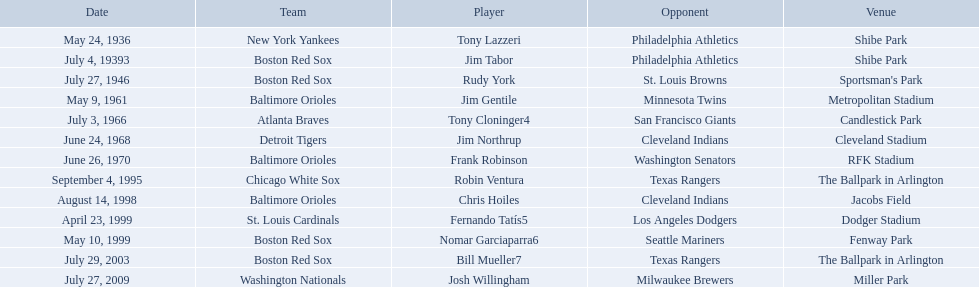What were the dates of each game? May 24, 1936, July 4, 19393, July 27, 1946, May 9, 1961, July 3, 1966, June 24, 1968, June 26, 1970, September 4, 1995, August 14, 1998, April 23, 1999, May 10, 1999, July 29, 2003, July 27, 2009. Who were all of the teams? New York Yankees, Boston Red Sox, Boston Red Sox, Baltimore Orioles, Atlanta Braves, Detroit Tigers, Baltimore Orioles, Chicago White Sox, Baltimore Orioles, St. Louis Cardinals, Boston Red Sox, Boston Red Sox, Washington Nationals. What about their opponents? Philadelphia Athletics, Philadelphia Athletics, St. Louis Browns, Minnesota Twins, San Francisco Giants, Cleveland Indians, Washington Senators, Texas Rangers, Cleveland Indians, Los Angeles Dodgers, Seattle Mariners, Texas Rangers, Milwaukee Brewers. And on which date did the detroit tigers play against the cleveland indians? June 24, 1968. 